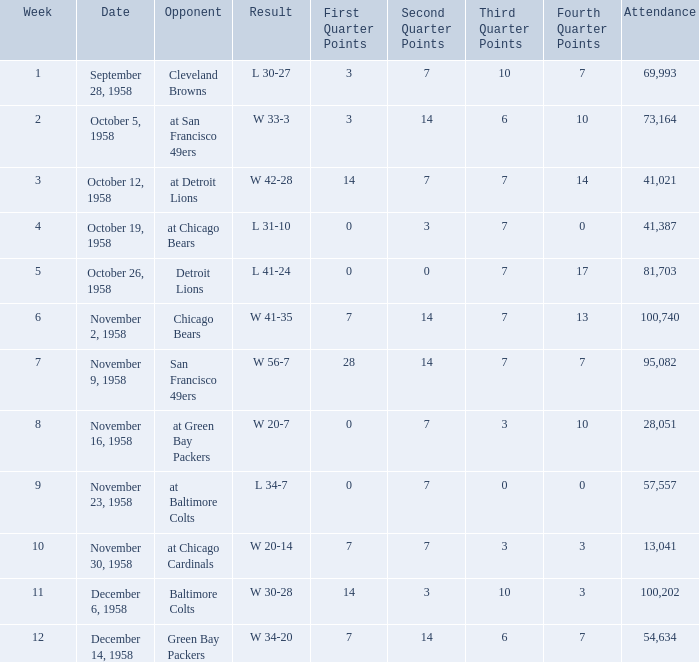What was the higest attendance on November 9, 1958? 95082.0. 